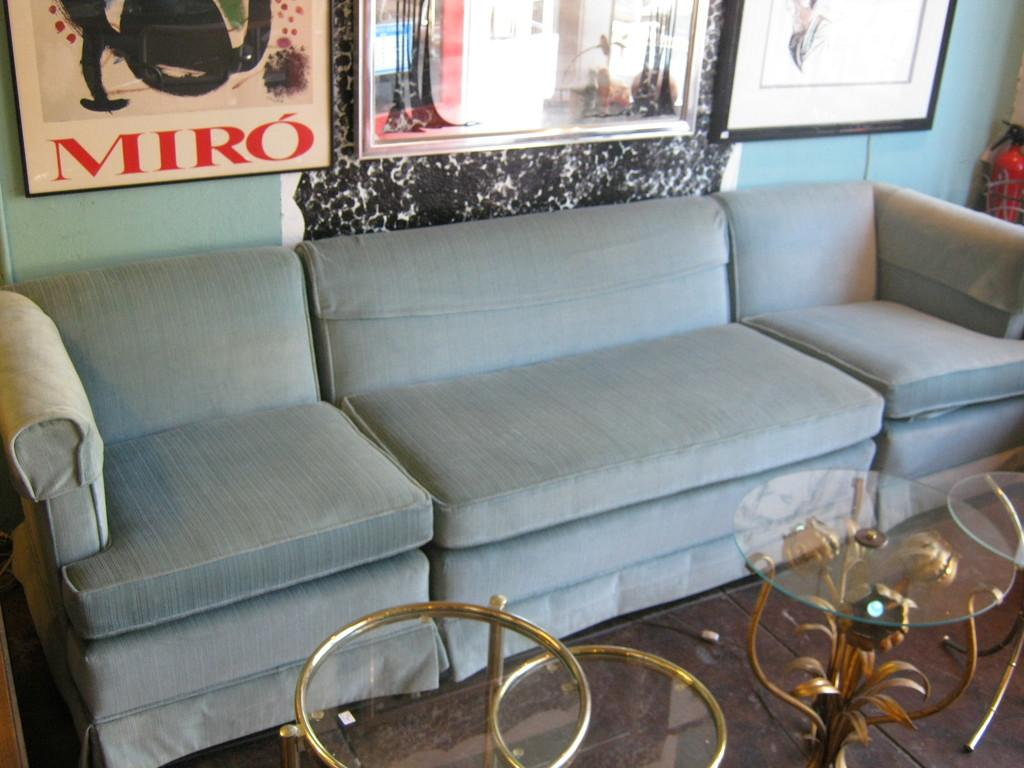What type of furniture is present in the image? There are sofas in the image. What is located in front of the sofas? There is a glass table in front of the sofas. What can be seen in the background of the image? There is a wall and a window in the background of the image. What is hanging on the wall in the image? There is a frame on the wall. How does the judge react to the disgusting behavior of the beginner in the image? There is no judge, disgusting behavior, or beginner present in the image. 